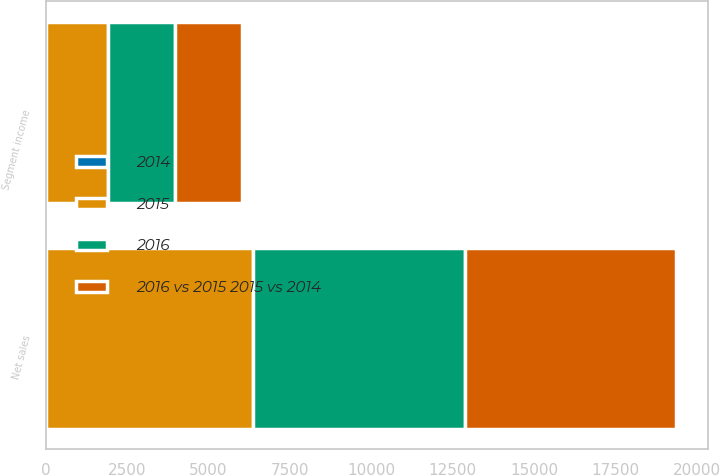Convert chart to OTSL. <chart><loc_0><loc_0><loc_500><loc_500><stacked_bar_chart><ecel><fcel>Net sales<fcel>Segment income<nl><fcel>2016<fcel>6533<fcel>2041<nl><fcel>2016 vs 2015 2015 vs 2014<fcel>6468.1<fcel>2074<nl><fcel>2015<fcel>6352.7<fcel>1916.2<nl><fcel>2014<fcel>1<fcel>1.6<nl></chart> 